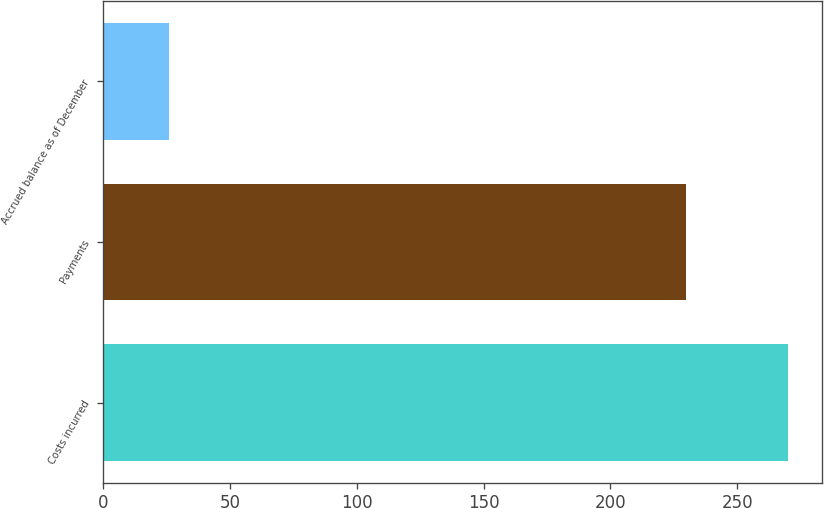<chart> <loc_0><loc_0><loc_500><loc_500><bar_chart><fcel>Costs incurred<fcel>Payments<fcel>Accrued balance as of December<nl><fcel>270<fcel>230<fcel>26<nl></chart> 